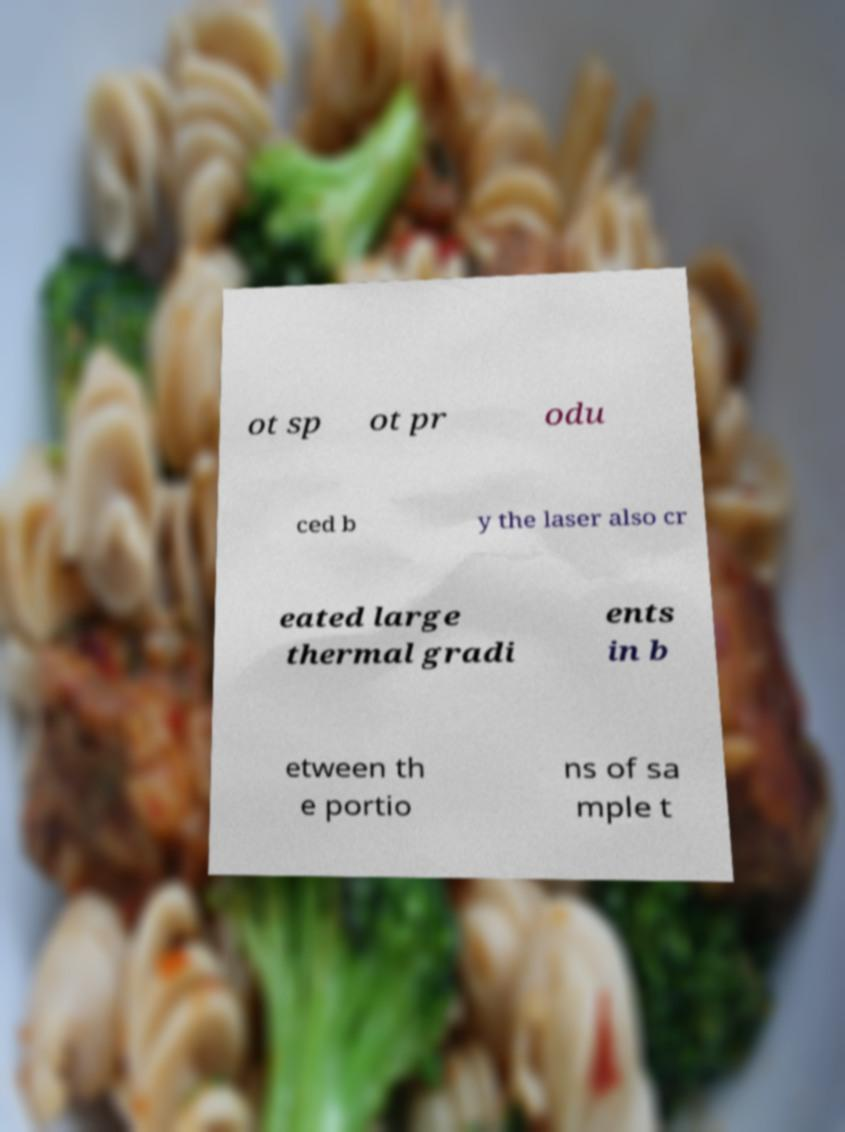Please read and relay the text visible in this image. What does it say? ot sp ot pr odu ced b y the laser also cr eated large thermal gradi ents in b etween th e portio ns of sa mple t 